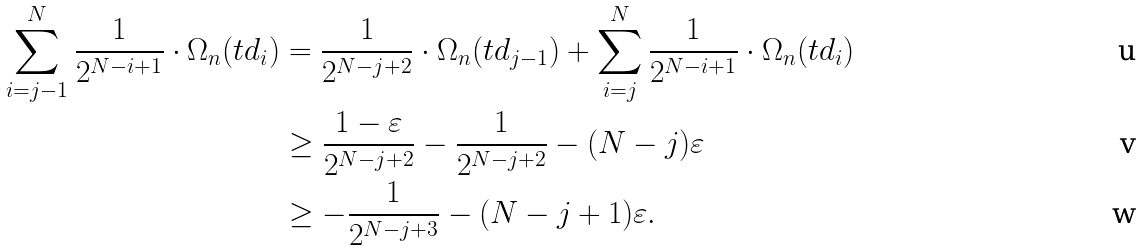Convert formula to latex. <formula><loc_0><loc_0><loc_500><loc_500>\sum _ { i = j - 1 } ^ { N } \frac { 1 } { 2 ^ { N - i + 1 } } \cdot \Omega _ { n } ( t d _ { i } ) & = \frac { 1 } { 2 ^ { N - j + 2 } } \cdot \Omega _ { n } ( t d _ { j - 1 } ) + \sum _ { i = j } ^ { N } \frac { 1 } { 2 ^ { N - i + 1 } } \cdot \Omega _ { n } ( t d _ { i } ) \\ & \geq \frac { 1 - \varepsilon } { 2 ^ { N - j + 2 } } - \frac { 1 } { 2 ^ { N - j + 2 } } - ( N - j ) \varepsilon \\ & \geq - \frac { 1 } { 2 ^ { N - j + 3 } } - ( N - j + 1 ) \varepsilon .</formula> 